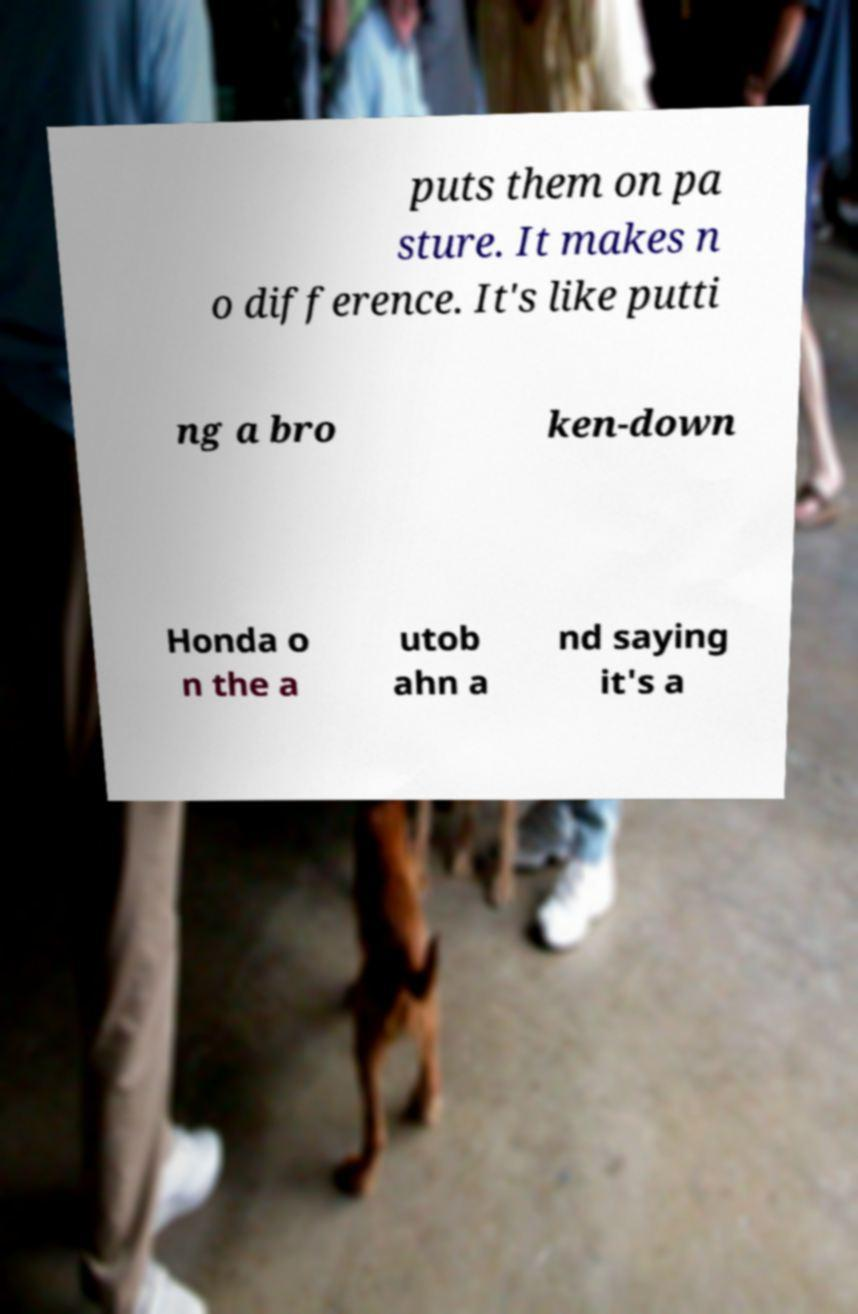I need the written content from this picture converted into text. Can you do that? puts them on pa sture. It makes n o difference. It's like putti ng a bro ken-down Honda o n the a utob ahn a nd saying it's a 